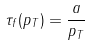<formula> <loc_0><loc_0><loc_500><loc_500>\tau _ { f } ( p _ { T } ) = \frac { a } { p _ { T } }</formula> 